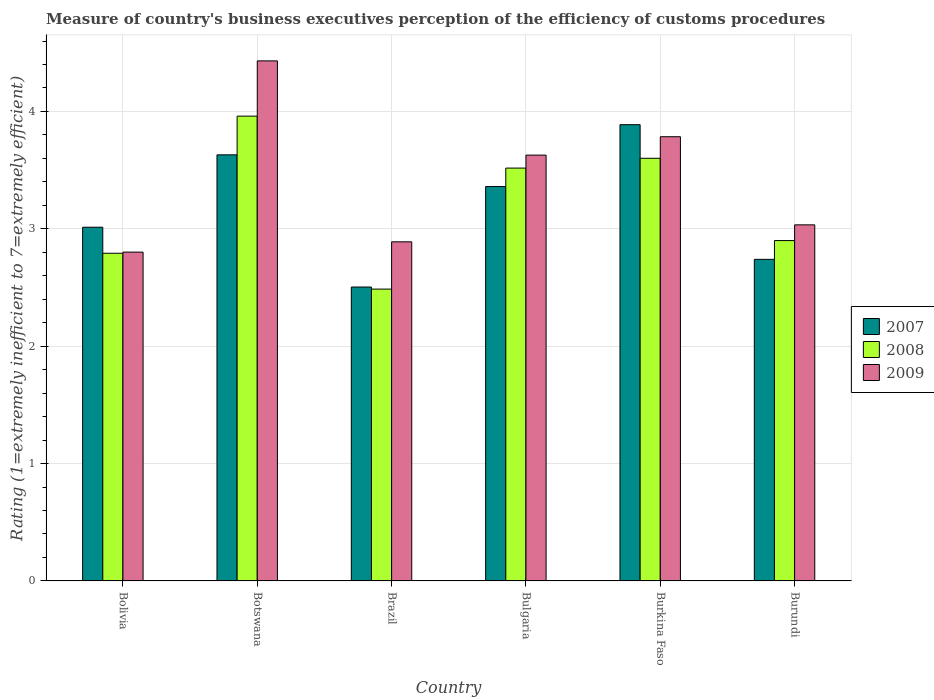How many different coloured bars are there?
Offer a terse response. 3. Are the number of bars per tick equal to the number of legend labels?
Your response must be concise. Yes. Are the number of bars on each tick of the X-axis equal?
Your answer should be compact. Yes. How many bars are there on the 3rd tick from the left?
Offer a terse response. 3. What is the label of the 4th group of bars from the left?
Give a very brief answer. Bulgaria. In how many cases, is the number of bars for a given country not equal to the number of legend labels?
Offer a very short reply. 0. What is the rating of the efficiency of customs procedure in 2008 in Botswana?
Your response must be concise. 3.96. Across all countries, what is the maximum rating of the efficiency of customs procedure in 2007?
Offer a very short reply. 3.89. Across all countries, what is the minimum rating of the efficiency of customs procedure in 2007?
Offer a terse response. 2.5. In which country was the rating of the efficiency of customs procedure in 2008 maximum?
Make the answer very short. Botswana. In which country was the rating of the efficiency of customs procedure in 2007 minimum?
Your answer should be very brief. Brazil. What is the total rating of the efficiency of customs procedure in 2007 in the graph?
Your answer should be very brief. 19.13. What is the difference between the rating of the efficiency of customs procedure in 2008 in Bulgaria and that in Burkina Faso?
Your answer should be compact. -0.08. What is the difference between the rating of the efficiency of customs procedure in 2007 in Botswana and the rating of the efficiency of customs procedure in 2008 in Bulgaria?
Give a very brief answer. 0.11. What is the average rating of the efficiency of customs procedure in 2009 per country?
Your answer should be very brief. 3.43. What is the difference between the rating of the efficiency of customs procedure of/in 2007 and rating of the efficiency of customs procedure of/in 2008 in Bolivia?
Give a very brief answer. 0.22. In how many countries, is the rating of the efficiency of customs procedure in 2009 greater than 3.4?
Offer a terse response. 3. What is the ratio of the rating of the efficiency of customs procedure in 2007 in Brazil to that in Burkina Faso?
Your answer should be very brief. 0.64. Is the rating of the efficiency of customs procedure in 2008 in Botswana less than that in Brazil?
Keep it short and to the point. No. What is the difference between the highest and the second highest rating of the efficiency of customs procedure in 2009?
Provide a succinct answer. -0.16. What is the difference between the highest and the lowest rating of the efficiency of customs procedure in 2009?
Give a very brief answer. 1.63. In how many countries, is the rating of the efficiency of customs procedure in 2007 greater than the average rating of the efficiency of customs procedure in 2007 taken over all countries?
Offer a terse response. 3. What does the 3rd bar from the right in Bulgaria represents?
Your answer should be very brief. 2007. Is it the case that in every country, the sum of the rating of the efficiency of customs procedure in 2009 and rating of the efficiency of customs procedure in 2007 is greater than the rating of the efficiency of customs procedure in 2008?
Make the answer very short. Yes. How many bars are there?
Provide a succinct answer. 18. Are all the bars in the graph horizontal?
Provide a succinct answer. No. What is the difference between two consecutive major ticks on the Y-axis?
Provide a short and direct response. 1. Does the graph contain any zero values?
Provide a succinct answer. No. How many legend labels are there?
Offer a very short reply. 3. What is the title of the graph?
Ensure brevity in your answer.  Measure of country's business executives perception of the efficiency of customs procedures. What is the label or title of the Y-axis?
Ensure brevity in your answer.  Rating (1=extremely inefficient to 7=extremely efficient). What is the Rating (1=extremely inefficient to 7=extremely efficient) of 2007 in Bolivia?
Provide a succinct answer. 3.01. What is the Rating (1=extremely inefficient to 7=extremely efficient) in 2008 in Bolivia?
Make the answer very short. 2.79. What is the Rating (1=extremely inefficient to 7=extremely efficient) of 2009 in Bolivia?
Keep it short and to the point. 2.8. What is the Rating (1=extremely inefficient to 7=extremely efficient) in 2007 in Botswana?
Keep it short and to the point. 3.63. What is the Rating (1=extremely inefficient to 7=extremely efficient) of 2008 in Botswana?
Your answer should be very brief. 3.96. What is the Rating (1=extremely inefficient to 7=extremely efficient) of 2009 in Botswana?
Provide a succinct answer. 4.43. What is the Rating (1=extremely inefficient to 7=extremely efficient) of 2007 in Brazil?
Your response must be concise. 2.5. What is the Rating (1=extremely inefficient to 7=extremely efficient) in 2008 in Brazil?
Make the answer very short. 2.49. What is the Rating (1=extremely inefficient to 7=extremely efficient) of 2009 in Brazil?
Your answer should be very brief. 2.89. What is the Rating (1=extremely inefficient to 7=extremely efficient) in 2007 in Bulgaria?
Your answer should be very brief. 3.36. What is the Rating (1=extremely inefficient to 7=extremely efficient) of 2008 in Bulgaria?
Your answer should be very brief. 3.52. What is the Rating (1=extremely inefficient to 7=extremely efficient) of 2009 in Bulgaria?
Provide a succinct answer. 3.63. What is the Rating (1=extremely inefficient to 7=extremely efficient) of 2007 in Burkina Faso?
Provide a short and direct response. 3.89. What is the Rating (1=extremely inefficient to 7=extremely efficient) in 2008 in Burkina Faso?
Ensure brevity in your answer.  3.6. What is the Rating (1=extremely inefficient to 7=extremely efficient) of 2009 in Burkina Faso?
Offer a very short reply. 3.78. What is the Rating (1=extremely inefficient to 7=extremely efficient) of 2007 in Burundi?
Offer a terse response. 2.74. What is the Rating (1=extremely inefficient to 7=extremely efficient) in 2008 in Burundi?
Your answer should be very brief. 2.9. What is the Rating (1=extremely inefficient to 7=extremely efficient) in 2009 in Burundi?
Provide a short and direct response. 3.03. Across all countries, what is the maximum Rating (1=extremely inefficient to 7=extremely efficient) of 2007?
Provide a succinct answer. 3.89. Across all countries, what is the maximum Rating (1=extremely inefficient to 7=extremely efficient) in 2008?
Provide a short and direct response. 3.96. Across all countries, what is the maximum Rating (1=extremely inefficient to 7=extremely efficient) of 2009?
Provide a short and direct response. 4.43. Across all countries, what is the minimum Rating (1=extremely inefficient to 7=extremely efficient) of 2007?
Keep it short and to the point. 2.5. Across all countries, what is the minimum Rating (1=extremely inefficient to 7=extremely efficient) in 2008?
Your answer should be compact. 2.49. Across all countries, what is the minimum Rating (1=extremely inefficient to 7=extremely efficient) of 2009?
Provide a short and direct response. 2.8. What is the total Rating (1=extremely inefficient to 7=extremely efficient) in 2007 in the graph?
Provide a succinct answer. 19.13. What is the total Rating (1=extremely inefficient to 7=extremely efficient) of 2008 in the graph?
Keep it short and to the point. 19.26. What is the total Rating (1=extremely inefficient to 7=extremely efficient) in 2009 in the graph?
Ensure brevity in your answer.  20.57. What is the difference between the Rating (1=extremely inefficient to 7=extremely efficient) of 2007 in Bolivia and that in Botswana?
Offer a terse response. -0.62. What is the difference between the Rating (1=extremely inefficient to 7=extremely efficient) of 2008 in Bolivia and that in Botswana?
Make the answer very short. -1.17. What is the difference between the Rating (1=extremely inefficient to 7=extremely efficient) of 2009 in Bolivia and that in Botswana?
Provide a short and direct response. -1.63. What is the difference between the Rating (1=extremely inefficient to 7=extremely efficient) in 2007 in Bolivia and that in Brazil?
Give a very brief answer. 0.51. What is the difference between the Rating (1=extremely inefficient to 7=extremely efficient) in 2008 in Bolivia and that in Brazil?
Ensure brevity in your answer.  0.31. What is the difference between the Rating (1=extremely inefficient to 7=extremely efficient) in 2009 in Bolivia and that in Brazil?
Keep it short and to the point. -0.09. What is the difference between the Rating (1=extremely inefficient to 7=extremely efficient) in 2007 in Bolivia and that in Bulgaria?
Provide a succinct answer. -0.35. What is the difference between the Rating (1=extremely inefficient to 7=extremely efficient) in 2008 in Bolivia and that in Bulgaria?
Your answer should be very brief. -0.73. What is the difference between the Rating (1=extremely inefficient to 7=extremely efficient) in 2009 in Bolivia and that in Bulgaria?
Ensure brevity in your answer.  -0.83. What is the difference between the Rating (1=extremely inefficient to 7=extremely efficient) of 2007 in Bolivia and that in Burkina Faso?
Provide a short and direct response. -0.87. What is the difference between the Rating (1=extremely inefficient to 7=extremely efficient) of 2008 in Bolivia and that in Burkina Faso?
Ensure brevity in your answer.  -0.81. What is the difference between the Rating (1=extremely inefficient to 7=extremely efficient) of 2009 in Bolivia and that in Burkina Faso?
Provide a succinct answer. -0.98. What is the difference between the Rating (1=extremely inefficient to 7=extremely efficient) of 2007 in Bolivia and that in Burundi?
Offer a terse response. 0.27. What is the difference between the Rating (1=extremely inefficient to 7=extremely efficient) in 2008 in Bolivia and that in Burundi?
Your response must be concise. -0.11. What is the difference between the Rating (1=extremely inefficient to 7=extremely efficient) of 2009 in Bolivia and that in Burundi?
Your response must be concise. -0.23. What is the difference between the Rating (1=extremely inefficient to 7=extremely efficient) in 2007 in Botswana and that in Brazil?
Your answer should be compact. 1.13. What is the difference between the Rating (1=extremely inefficient to 7=extremely efficient) in 2008 in Botswana and that in Brazil?
Make the answer very short. 1.47. What is the difference between the Rating (1=extremely inefficient to 7=extremely efficient) in 2009 in Botswana and that in Brazil?
Give a very brief answer. 1.54. What is the difference between the Rating (1=extremely inefficient to 7=extremely efficient) in 2007 in Botswana and that in Bulgaria?
Provide a short and direct response. 0.27. What is the difference between the Rating (1=extremely inefficient to 7=extremely efficient) of 2008 in Botswana and that in Bulgaria?
Your answer should be compact. 0.44. What is the difference between the Rating (1=extremely inefficient to 7=extremely efficient) of 2009 in Botswana and that in Bulgaria?
Make the answer very short. 0.8. What is the difference between the Rating (1=extremely inefficient to 7=extremely efficient) in 2007 in Botswana and that in Burkina Faso?
Make the answer very short. -0.26. What is the difference between the Rating (1=extremely inefficient to 7=extremely efficient) of 2008 in Botswana and that in Burkina Faso?
Your answer should be very brief. 0.36. What is the difference between the Rating (1=extremely inefficient to 7=extremely efficient) in 2009 in Botswana and that in Burkina Faso?
Provide a short and direct response. 0.65. What is the difference between the Rating (1=extremely inefficient to 7=extremely efficient) in 2007 in Botswana and that in Burundi?
Keep it short and to the point. 0.89. What is the difference between the Rating (1=extremely inefficient to 7=extremely efficient) in 2008 in Botswana and that in Burundi?
Keep it short and to the point. 1.06. What is the difference between the Rating (1=extremely inefficient to 7=extremely efficient) in 2009 in Botswana and that in Burundi?
Your answer should be compact. 1.4. What is the difference between the Rating (1=extremely inefficient to 7=extremely efficient) in 2007 in Brazil and that in Bulgaria?
Provide a short and direct response. -0.86. What is the difference between the Rating (1=extremely inefficient to 7=extremely efficient) in 2008 in Brazil and that in Bulgaria?
Your answer should be very brief. -1.03. What is the difference between the Rating (1=extremely inefficient to 7=extremely efficient) of 2009 in Brazil and that in Bulgaria?
Offer a very short reply. -0.74. What is the difference between the Rating (1=extremely inefficient to 7=extremely efficient) in 2007 in Brazil and that in Burkina Faso?
Offer a terse response. -1.38. What is the difference between the Rating (1=extremely inefficient to 7=extremely efficient) in 2008 in Brazil and that in Burkina Faso?
Ensure brevity in your answer.  -1.11. What is the difference between the Rating (1=extremely inefficient to 7=extremely efficient) in 2009 in Brazil and that in Burkina Faso?
Ensure brevity in your answer.  -0.9. What is the difference between the Rating (1=extremely inefficient to 7=extremely efficient) in 2007 in Brazil and that in Burundi?
Your response must be concise. -0.24. What is the difference between the Rating (1=extremely inefficient to 7=extremely efficient) of 2008 in Brazil and that in Burundi?
Make the answer very short. -0.41. What is the difference between the Rating (1=extremely inefficient to 7=extremely efficient) in 2009 in Brazil and that in Burundi?
Offer a terse response. -0.14. What is the difference between the Rating (1=extremely inefficient to 7=extremely efficient) in 2007 in Bulgaria and that in Burkina Faso?
Your response must be concise. -0.53. What is the difference between the Rating (1=extremely inefficient to 7=extremely efficient) in 2008 in Bulgaria and that in Burkina Faso?
Your answer should be compact. -0.08. What is the difference between the Rating (1=extremely inefficient to 7=extremely efficient) in 2009 in Bulgaria and that in Burkina Faso?
Your answer should be very brief. -0.16. What is the difference between the Rating (1=extremely inefficient to 7=extremely efficient) of 2007 in Bulgaria and that in Burundi?
Provide a short and direct response. 0.62. What is the difference between the Rating (1=extremely inefficient to 7=extremely efficient) of 2008 in Bulgaria and that in Burundi?
Your response must be concise. 0.62. What is the difference between the Rating (1=extremely inefficient to 7=extremely efficient) of 2009 in Bulgaria and that in Burundi?
Offer a terse response. 0.59. What is the difference between the Rating (1=extremely inefficient to 7=extremely efficient) of 2007 in Burkina Faso and that in Burundi?
Provide a succinct answer. 1.15. What is the difference between the Rating (1=extremely inefficient to 7=extremely efficient) in 2008 in Burkina Faso and that in Burundi?
Ensure brevity in your answer.  0.7. What is the difference between the Rating (1=extremely inefficient to 7=extremely efficient) of 2009 in Burkina Faso and that in Burundi?
Provide a succinct answer. 0.75. What is the difference between the Rating (1=extremely inefficient to 7=extremely efficient) of 2007 in Bolivia and the Rating (1=extremely inefficient to 7=extremely efficient) of 2008 in Botswana?
Offer a terse response. -0.95. What is the difference between the Rating (1=extremely inefficient to 7=extremely efficient) of 2007 in Bolivia and the Rating (1=extremely inefficient to 7=extremely efficient) of 2009 in Botswana?
Offer a very short reply. -1.42. What is the difference between the Rating (1=extremely inefficient to 7=extremely efficient) in 2008 in Bolivia and the Rating (1=extremely inefficient to 7=extremely efficient) in 2009 in Botswana?
Your answer should be compact. -1.64. What is the difference between the Rating (1=extremely inefficient to 7=extremely efficient) in 2007 in Bolivia and the Rating (1=extremely inefficient to 7=extremely efficient) in 2008 in Brazil?
Ensure brevity in your answer.  0.53. What is the difference between the Rating (1=extremely inefficient to 7=extremely efficient) of 2007 in Bolivia and the Rating (1=extremely inefficient to 7=extremely efficient) of 2009 in Brazil?
Give a very brief answer. 0.12. What is the difference between the Rating (1=extremely inefficient to 7=extremely efficient) of 2008 in Bolivia and the Rating (1=extremely inefficient to 7=extremely efficient) of 2009 in Brazil?
Ensure brevity in your answer.  -0.1. What is the difference between the Rating (1=extremely inefficient to 7=extremely efficient) in 2007 in Bolivia and the Rating (1=extremely inefficient to 7=extremely efficient) in 2008 in Bulgaria?
Ensure brevity in your answer.  -0.5. What is the difference between the Rating (1=extremely inefficient to 7=extremely efficient) of 2007 in Bolivia and the Rating (1=extremely inefficient to 7=extremely efficient) of 2009 in Bulgaria?
Ensure brevity in your answer.  -0.61. What is the difference between the Rating (1=extremely inefficient to 7=extremely efficient) in 2008 in Bolivia and the Rating (1=extremely inefficient to 7=extremely efficient) in 2009 in Bulgaria?
Make the answer very short. -0.84. What is the difference between the Rating (1=extremely inefficient to 7=extremely efficient) of 2007 in Bolivia and the Rating (1=extremely inefficient to 7=extremely efficient) of 2008 in Burkina Faso?
Give a very brief answer. -0.59. What is the difference between the Rating (1=extremely inefficient to 7=extremely efficient) of 2007 in Bolivia and the Rating (1=extremely inefficient to 7=extremely efficient) of 2009 in Burkina Faso?
Offer a very short reply. -0.77. What is the difference between the Rating (1=extremely inefficient to 7=extremely efficient) of 2008 in Bolivia and the Rating (1=extremely inefficient to 7=extremely efficient) of 2009 in Burkina Faso?
Your answer should be compact. -0.99. What is the difference between the Rating (1=extremely inefficient to 7=extremely efficient) in 2007 in Bolivia and the Rating (1=extremely inefficient to 7=extremely efficient) in 2008 in Burundi?
Offer a very short reply. 0.11. What is the difference between the Rating (1=extremely inefficient to 7=extremely efficient) of 2007 in Bolivia and the Rating (1=extremely inefficient to 7=extremely efficient) of 2009 in Burundi?
Provide a succinct answer. -0.02. What is the difference between the Rating (1=extremely inefficient to 7=extremely efficient) in 2008 in Bolivia and the Rating (1=extremely inefficient to 7=extremely efficient) in 2009 in Burundi?
Keep it short and to the point. -0.24. What is the difference between the Rating (1=extremely inefficient to 7=extremely efficient) in 2007 in Botswana and the Rating (1=extremely inefficient to 7=extremely efficient) in 2008 in Brazil?
Offer a terse response. 1.14. What is the difference between the Rating (1=extremely inefficient to 7=extremely efficient) of 2007 in Botswana and the Rating (1=extremely inefficient to 7=extremely efficient) of 2009 in Brazil?
Your response must be concise. 0.74. What is the difference between the Rating (1=extremely inefficient to 7=extremely efficient) in 2008 in Botswana and the Rating (1=extremely inefficient to 7=extremely efficient) in 2009 in Brazil?
Offer a terse response. 1.07. What is the difference between the Rating (1=extremely inefficient to 7=extremely efficient) of 2007 in Botswana and the Rating (1=extremely inefficient to 7=extremely efficient) of 2008 in Bulgaria?
Provide a succinct answer. 0.11. What is the difference between the Rating (1=extremely inefficient to 7=extremely efficient) of 2007 in Botswana and the Rating (1=extremely inefficient to 7=extremely efficient) of 2009 in Bulgaria?
Give a very brief answer. 0. What is the difference between the Rating (1=extremely inefficient to 7=extremely efficient) in 2008 in Botswana and the Rating (1=extremely inefficient to 7=extremely efficient) in 2009 in Bulgaria?
Keep it short and to the point. 0.33. What is the difference between the Rating (1=extremely inefficient to 7=extremely efficient) of 2007 in Botswana and the Rating (1=extremely inefficient to 7=extremely efficient) of 2008 in Burkina Faso?
Your answer should be compact. 0.03. What is the difference between the Rating (1=extremely inefficient to 7=extremely efficient) of 2007 in Botswana and the Rating (1=extremely inefficient to 7=extremely efficient) of 2009 in Burkina Faso?
Keep it short and to the point. -0.15. What is the difference between the Rating (1=extremely inefficient to 7=extremely efficient) of 2008 in Botswana and the Rating (1=extremely inefficient to 7=extremely efficient) of 2009 in Burkina Faso?
Keep it short and to the point. 0.18. What is the difference between the Rating (1=extremely inefficient to 7=extremely efficient) in 2007 in Botswana and the Rating (1=extremely inefficient to 7=extremely efficient) in 2008 in Burundi?
Offer a very short reply. 0.73. What is the difference between the Rating (1=extremely inefficient to 7=extremely efficient) in 2007 in Botswana and the Rating (1=extremely inefficient to 7=extremely efficient) in 2009 in Burundi?
Your answer should be very brief. 0.6. What is the difference between the Rating (1=extremely inefficient to 7=extremely efficient) in 2008 in Botswana and the Rating (1=extremely inefficient to 7=extremely efficient) in 2009 in Burundi?
Give a very brief answer. 0.93. What is the difference between the Rating (1=extremely inefficient to 7=extremely efficient) in 2007 in Brazil and the Rating (1=extremely inefficient to 7=extremely efficient) in 2008 in Bulgaria?
Your answer should be compact. -1.01. What is the difference between the Rating (1=extremely inefficient to 7=extremely efficient) of 2007 in Brazil and the Rating (1=extremely inefficient to 7=extremely efficient) of 2009 in Bulgaria?
Offer a terse response. -1.12. What is the difference between the Rating (1=extremely inefficient to 7=extremely efficient) in 2008 in Brazil and the Rating (1=extremely inefficient to 7=extremely efficient) in 2009 in Bulgaria?
Your answer should be very brief. -1.14. What is the difference between the Rating (1=extremely inefficient to 7=extremely efficient) of 2007 in Brazil and the Rating (1=extremely inefficient to 7=extremely efficient) of 2008 in Burkina Faso?
Keep it short and to the point. -1.1. What is the difference between the Rating (1=extremely inefficient to 7=extremely efficient) of 2007 in Brazil and the Rating (1=extremely inefficient to 7=extremely efficient) of 2009 in Burkina Faso?
Your answer should be very brief. -1.28. What is the difference between the Rating (1=extremely inefficient to 7=extremely efficient) of 2008 in Brazil and the Rating (1=extremely inefficient to 7=extremely efficient) of 2009 in Burkina Faso?
Offer a terse response. -1.3. What is the difference between the Rating (1=extremely inefficient to 7=extremely efficient) of 2007 in Brazil and the Rating (1=extremely inefficient to 7=extremely efficient) of 2008 in Burundi?
Your answer should be very brief. -0.4. What is the difference between the Rating (1=extremely inefficient to 7=extremely efficient) of 2007 in Brazil and the Rating (1=extremely inefficient to 7=extremely efficient) of 2009 in Burundi?
Your answer should be very brief. -0.53. What is the difference between the Rating (1=extremely inefficient to 7=extremely efficient) of 2008 in Brazil and the Rating (1=extremely inefficient to 7=extremely efficient) of 2009 in Burundi?
Make the answer very short. -0.55. What is the difference between the Rating (1=extremely inefficient to 7=extremely efficient) of 2007 in Bulgaria and the Rating (1=extremely inefficient to 7=extremely efficient) of 2008 in Burkina Faso?
Your response must be concise. -0.24. What is the difference between the Rating (1=extremely inefficient to 7=extremely efficient) of 2007 in Bulgaria and the Rating (1=extremely inefficient to 7=extremely efficient) of 2009 in Burkina Faso?
Ensure brevity in your answer.  -0.42. What is the difference between the Rating (1=extremely inefficient to 7=extremely efficient) in 2008 in Bulgaria and the Rating (1=extremely inefficient to 7=extremely efficient) in 2009 in Burkina Faso?
Provide a short and direct response. -0.27. What is the difference between the Rating (1=extremely inefficient to 7=extremely efficient) in 2007 in Bulgaria and the Rating (1=extremely inefficient to 7=extremely efficient) in 2008 in Burundi?
Provide a short and direct response. 0.46. What is the difference between the Rating (1=extremely inefficient to 7=extremely efficient) of 2007 in Bulgaria and the Rating (1=extremely inefficient to 7=extremely efficient) of 2009 in Burundi?
Ensure brevity in your answer.  0.33. What is the difference between the Rating (1=extremely inefficient to 7=extremely efficient) of 2008 in Bulgaria and the Rating (1=extremely inefficient to 7=extremely efficient) of 2009 in Burundi?
Provide a short and direct response. 0.48. What is the difference between the Rating (1=extremely inefficient to 7=extremely efficient) in 2007 in Burkina Faso and the Rating (1=extremely inefficient to 7=extremely efficient) in 2008 in Burundi?
Ensure brevity in your answer.  0.99. What is the difference between the Rating (1=extremely inefficient to 7=extremely efficient) in 2007 in Burkina Faso and the Rating (1=extremely inefficient to 7=extremely efficient) in 2009 in Burundi?
Your answer should be compact. 0.85. What is the difference between the Rating (1=extremely inefficient to 7=extremely efficient) of 2008 in Burkina Faso and the Rating (1=extremely inefficient to 7=extremely efficient) of 2009 in Burundi?
Give a very brief answer. 0.57. What is the average Rating (1=extremely inefficient to 7=extremely efficient) of 2007 per country?
Ensure brevity in your answer.  3.19. What is the average Rating (1=extremely inefficient to 7=extremely efficient) in 2008 per country?
Your response must be concise. 3.21. What is the average Rating (1=extremely inefficient to 7=extremely efficient) in 2009 per country?
Provide a short and direct response. 3.43. What is the difference between the Rating (1=extremely inefficient to 7=extremely efficient) in 2007 and Rating (1=extremely inefficient to 7=extremely efficient) in 2008 in Bolivia?
Provide a succinct answer. 0.22. What is the difference between the Rating (1=extremely inefficient to 7=extremely efficient) of 2007 and Rating (1=extremely inefficient to 7=extremely efficient) of 2009 in Bolivia?
Your answer should be compact. 0.21. What is the difference between the Rating (1=extremely inefficient to 7=extremely efficient) of 2008 and Rating (1=extremely inefficient to 7=extremely efficient) of 2009 in Bolivia?
Your answer should be compact. -0.01. What is the difference between the Rating (1=extremely inefficient to 7=extremely efficient) of 2007 and Rating (1=extremely inefficient to 7=extremely efficient) of 2008 in Botswana?
Provide a succinct answer. -0.33. What is the difference between the Rating (1=extremely inefficient to 7=extremely efficient) in 2007 and Rating (1=extremely inefficient to 7=extremely efficient) in 2009 in Botswana?
Provide a succinct answer. -0.8. What is the difference between the Rating (1=extremely inefficient to 7=extremely efficient) in 2008 and Rating (1=extremely inefficient to 7=extremely efficient) in 2009 in Botswana?
Give a very brief answer. -0.47. What is the difference between the Rating (1=extremely inefficient to 7=extremely efficient) of 2007 and Rating (1=extremely inefficient to 7=extremely efficient) of 2008 in Brazil?
Ensure brevity in your answer.  0.02. What is the difference between the Rating (1=extremely inefficient to 7=extremely efficient) of 2007 and Rating (1=extremely inefficient to 7=extremely efficient) of 2009 in Brazil?
Offer a terse response. -0.39. What is the difference between the Rating (1=extremely inefficient to 7=extremely efficient) in 2008 and Rating (1=extremely inefficient to 7=extremely efficient) in 2009 in Brazil?
Offer a very short reply. -0.4. What is the difference between the Rating (1=extremely inefficient to 7=extremely efficient) of 2007 and Rating (1=extremely inefficient to 7=extremely efficient) of 2008 in Bulgaria?
Offer a terse response. -0.16. What is the difference between the Rating (1=extremely inefficient to 7=extremely efficient) in 2007 and Rating (1=extremely inefficient to 7=extremely efficient) in 2009 in Bulgaria?
Offer a terse response. -0.27. What is the difference between the Rating (1=extremely inefficient to 7=extremely efficient) in 2008 and Rating (1=extremely inefficient to 7=extremely efficient) in 2009 in Bulgaria?
Provide a short and direct response. -0.11. What is the difference between the Rating (1=extremely inefficient to 7=extremely efficient) in 2007 and Rating (1=extremely inefficient to 7=extremely efficient) in 2008 in Burkina Faso?
Offer a terse response. 0.29. What is the difference between the Rating (1=extremely inefficient to 7=extremely efficient) in 2007 and Rating (1=extremely inefficient to 7=extremely efficient) in 2009 in Burkina Faso?
Ensure brevity in your answer.  0.1. What is the difference between the Rating (1=extremely inefficient to 7=extremely efficient) in 2008 and Rating (1=extremely inefficient to 7=extremely efficient) in 2009 in Burkina Faso?
Your response must be concise. -0.18. What is the difference between the Rating (1=extremely inefficient to 7=extremely efficient) in 2007 and Rating (1=extremely inefficient to 7=extremely efficient) in 2008 in Burundi?
Provide a succinct answer. -0.16. What is the difference between the Rating (1=extremely inefficient to 7=extremely efficient) of 2007 and Rating (1=extremely inefficient to 7=extremely efficient) of 2009 in Burundi?
Your answer should be compact. -0.29. What is the difference between the Rating (1=extremely inefficient to 7=extremely efficient) of 2008 and Rating (1=extremely inefficient to 7=extremely efficient) of 2009 in Burundi?
Your answer should be very brief. -0.13. What is the ratio of the Rating (1=extremely inefficient to 7=extremely efficient) in 2007 in Bolivia to that in Botswana?
Offer a terse response. 0.83. What is the ratio of the Rating (1=extremely inefficient to 7=extremely efficient) of 2008 in Bolivia to that in Botswana?
Provide a succinct answer. 0.7. What is the ratio of the Rating (1=extremely inefficient to 7=extremely efficient) in 2009 in Bolivia to that in Botswana?
Provide a succinct answer. 0.63. What is the ratio of the Rating (1=extremely inefficient to 7=extremely efficient) of 2007 in Bolivia to that in Brazil?
Your answer should be very brief. 1.2. What is the ratio of the Rating (1=extremely inefficient to 7=extremely efficient) of 2008 in Bolivia to that in Brazil?
Provide a succinct answer. 1.12. What is the ratio of the Rating (1=extremely inefficient to 7=extremely efficient) in 2009 in Bolivia to that in Brazil?
Make the answer very short. 0.97. What is the ratio of the Rating (1=extremely inefficient to 7=extremely efficient) of 2007 in Bolivia to that in Bulgaria?
Provide a succinct answer. 0.9. What is the ratio of the Rating (1=extremely inefficient to 7=extremely efficient) in 2008 in Bolivia to that in Bulgaria?
Make the answer very short. 0.79. What is the ratio of the Rating (1=extremely inefficient to 7=extremely efficient) of 2009 in Bolivia to that in Bulgaria?
Your answer should be very brief. 0.77. What is the ratio of the Rating (1=extremely inefficient to 7=extremely efficient) in 2007 in Bolivia to that in Burkina Faso?
Ensure brevity in your answer.  0.78. What is the ratio of the Rating (1=extremely inefficient to 7=extremely efficient) of 2008 in Bolivia to that in Burkina Faso?
Make the answer very short. 0.78. What is the ratio of the Rating (1=extremely inefficient to 7=extremely efficient) of 2009 in Bolivia to that in Burkina Faso?
Offer a very short reply. 0.74. What is the ratio of the Rating (1=extremely inefficient to 7=extremely efficient) of 2007 in Bolivia to that in Burundi?
Your answer should be compact. 1.1. What is the ratio of the Rating (1=extremely inefficient to 7=extremely efficient) of 2008 in Bolivia to that in Burundi?
Offer a terse response. 0.96. What is the ratio of the Rating (1=extremely inefficient to 7=extremely efficient) of 2009 in Bolivia to that in Burundi?
Ensure brevity in your answer.  0.92. What is the ratio of the Rating (1=extremely inefficient to 7=extremely efficient) of 2007 in Botswana to that in Brazil?
Make the answer very short. 1.45. What is the ratio of the Rating (1=extremely inefficient to 7=extremely efficient) in 2008 in Botswana to that in Brazil?
Provide a succinct answer. 1.59. What is the ratio of the Rating (1=extremely inefficient to 7=extremely efficient) in 2009 in Botswana to that in Brazil?
Offer a terse response. 1.53. What is the ratio of the Rating (1=extremely inefficient to 7=extremely efficient) of 2007 in Botswana to that in Bulgaria?
Offer a very short reply. 1.08. What is the ratio of the Rating (1=extremely inefficient to 7=extremely efficient) of 2008 in Botswana to that in Bulgaria?
Provide a short and direct response. 1.13. What is the ratio of the Rating (1=extremely inefficient to 7=extremely efficient) in 2009 in Botswana to that in Bulgaria?
Ensure brevity in your answer.  1.22. What is the ratio of the Rating (1=extremely inefficient to 7=extremely efficient) in 2007 in Botswana to that in Burkina Faso?
Keep it short and to the point. 0.93. What is the ratio of the Rating (1=extremely inefficient to 7=extremely efficient) of 2008 in Botswana to that in Burkina Faso?
Provide a succinct answer. 1.1. What is the ratio of the Rating (1=extremely inefficient to 7=extremely efficient) of 2009 in Botswana to that in Burkina Faso?
Offer a terse response. 1.17. What is the ratio of the Rating (1=extremely inefficient to 7=extremely efficient) in 2007 in Botswana to that in Burundi?
Your answer should be very brief. 1.32. What is the ratio of the Rating (1=extremely inefficient to 7=extremely efficient) of 2008 in Botswana to that in Burundi?
Your response must be concise. 1.37. What is the ratio of the Rating (1=extremely inefficient to 7=extremely efficient) in 2009 in Botswana to that in Burundi?
Your answer should be compact. 1.46. What is the ratio of the Rating (1=extremely inefficient to 7=extremely efficient) of 2007 in Brazil to that in Bulgaria?
Offer a very short reply. 0.75. What is the ratio of the Rating (1=extremely inefficient to 7=extremely efficient) of 2008 in Brazil to that in Bulgaria?
Make the answer very short. 0.71. What is the ratio of the Rating (1=extremely inefficient to 7=extremely efficient) of 2009 in Brazil to that in Bulgaria?
Make the answer very short. 0.8. What is the ratio of the Rating (1=extremely inefficient to 7=extremely efficient) of 2007 in Brazil to that in Burkina Faso?
Ensure brevity in your answer.  0.64. What is the ratio of the Rating (1=extremely inefficient to 7=extremely efficient) of 2008 in Brazil to that in Burkina Faso?
Provide a succinct answer. 0.69. What is the ratio of the Rating (1=extremely inefficient to 7=extremely efficient) of 2009 in Brazil to that in Burkina Faso?
Ensure brevity in your answer.  0.76. What is the ratio of the Rating (1=extremely inefficient to 7=extremely efficient) in 2007 in Brazil to that in Burundi?
Keep it short and to the point. 0.91. What is the ratio of the Rating (1=extremely inefficient to 7=extremely efficient) in 2008 in Brazil to that in Burundi?
Your answer should be compact. 0.86. What is the ratio of the Rating (1=extremely inefficient to 7=extremely efficient) of 2007 in Bulgaria to that in Burkina Faso?
Offer a very short reply. 0.86. What is the ratio of the Rating (1=extremely inefficient to 7=extremely efficient) in 2008 in Bulgaria to that in Burkina Faso?
Your answer should be very brief. 0.98. What is the ratio of the Rating (1=extremely inefficient to 7=extremely efficient) of 2009 in Bulgaria to that in Burkina Faso?
Make the answer very short. 0.96. What is the ratio of the Rating (1=extremely inefficient to 7=extremely efficient) of 2007 in Bulgaria to that in Burundi?
Give a very brief answer. 1.23. What is the ratio of the Rating (1=extremely inefficient to 7=extremely efficient) of 2008 in Bulgaria to that in Burundi?
Offer a terse response. 1.21. What is the ratio of the Rating (1=extremely inefficient to 7=extremely efficient) in 2009 in Bulgaria to that in Burundi?
Make the answer very short. 1.2. What is the ratio of the Rating (1=extremely inefficient to 7=extremely efficient) in 2007 in Burkina Faso to that in Burundi?
Ensure brevity in your answer.  1.42. What is the ratio of the Rating (1=extremely inefficient to 7=extremely efficient) of 2008 in Burkina Faso to that in Burundi?
Give a very brief answer. 1.24. What is the ratio of the Rating (1=extremely inefficient to 7=extremely efficient) of 2009 in Burkina Faso to that in Burundi?
Your response must be concise. 1.25. What is the difference between the highest and the second highest Rating (1=extremely inefficient to 7=extremely efficient) in 2007?
Offer a terse response. 0.26. What is the difference between the highest and the second highest Rating (1=extremely inefficient to 7=extremely efficient) of 2008?
Offer a very short reply. 0.36. What is the difference between the highest and the second highest Rating (1=extremely inefficient to 7=extremely efficient) of 2009?
Ensure brevity in your answer.  0.65. What is the difference between the highest and the lowest Rating (1=extremely inefficient to 7=extremely efficient) in 2007?
Offer a very short reply. 1.38. What is the difference between the highest and the lowest Rating (1=extremely inefficient to 7=extremely efficient) of 2008?
Your answer should be compact. 1.47. What is the difference between the highest and the lowest Rating (1=extremely inefficient to 7=extremely efficient) in 2009?
Offer a very short reply. 1.63. 